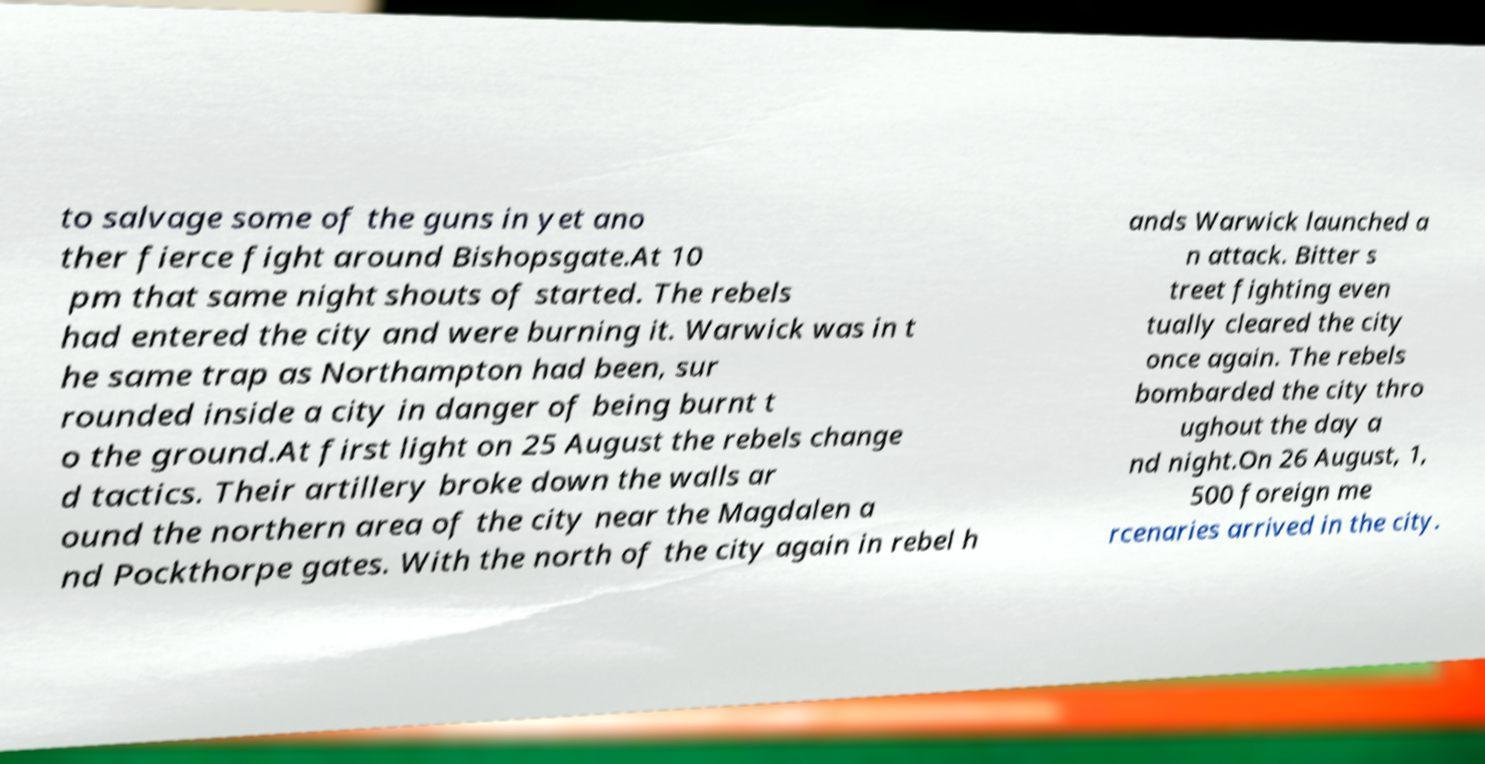I need the written content from this picture converted into text. Can you do that? to salvage some of the guns in yet ano ther fierce fight around Bishopsgate.At 10 pm that same night shouts of started. The rebels had entered the city and were burning it. Warwick was in t he same trap as Northampton had been, sur rounded inside a city in danger of being burnt t o the ground.At first light on 25 August the rebels change d tactics. Their artillery broke down the walls ar ound the northern area of the city near the Magdalen a nd Pockthorpe gates. With the north of the city again in rebel h ands Warwick launched a n attack. Bitter s treet fighting even tually cleared the city once again. The rebels bombarded the city thro ughout the day a nd night.On 26 August, 1, 500 foreign me rcenaries arrived in the city. 